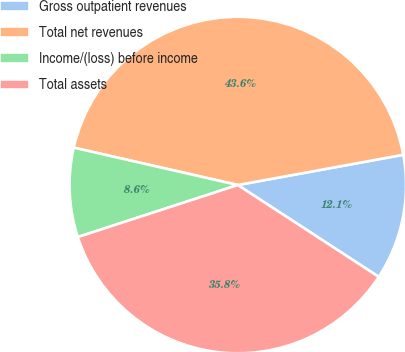Convert chart to OTSL. <chart><loc_0><loc_0><loc_500><loc_500><pie_chart><fcel>Gross outpatient revenues<fcel>Total net revenues<fcel>Income/(loss) before income<fcel>Total assets<nl><fcel>12.07%<fcel>43.56%<fcel>8.57%<fcel>35.81%<nl></chart> 